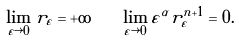<formula> <loc_0><loc_0><loc_500><loc_500>\lim _ { \varepsilon \rightarrow 0 } r _ { \varepsilon } = + \infty \quad \lim _ { \varepsilon \rightarrow 0 } \varepsilon ^ { \alpha } r _ { \varepsilon } ^ { n + 1 } = 0 .</formula> 